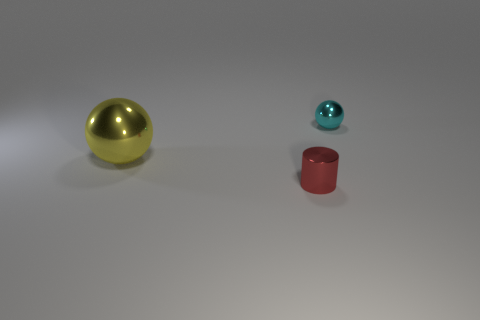Is there any other thing that is the same size as the yellow metal thing?
Make the answer very short. No. What color is the metallic ball on the right side of the yellow metal thing?
Your answer should be compact. Cyan. What is the material of the sphere that is on the right side of the small shiny object that is left of the object behind the big yellow sphere?
Your answer should be very brief. Metal. Is there a small red metallic object of the same shape as the yellow object?
Provide a succinct answer. No. The red object that is the same size as the cyan metallic sphere is what shape?
Make the answer very short. Cylinder. What number of shiny things are both to the left of the cyan metallic ball and on the right side of the yellow sphere?
Your response must be concise. 1. Is the number of metal cylinders to the left of the small red shiny cylinder less than the number of tiny cyan metal balls?
Provide a succinct answer. Yes. Are there any other yellow shiny balls of the same size as the yellow sphere?
Provide a short and direct response. No. What is the color of the large ball that is the same material as the red object?
Provide a succinct answer. Yellow. How many cylinders are on the right side of the ball that is left of the small red cylinder?
Ensure brevity in your answer.  1. 